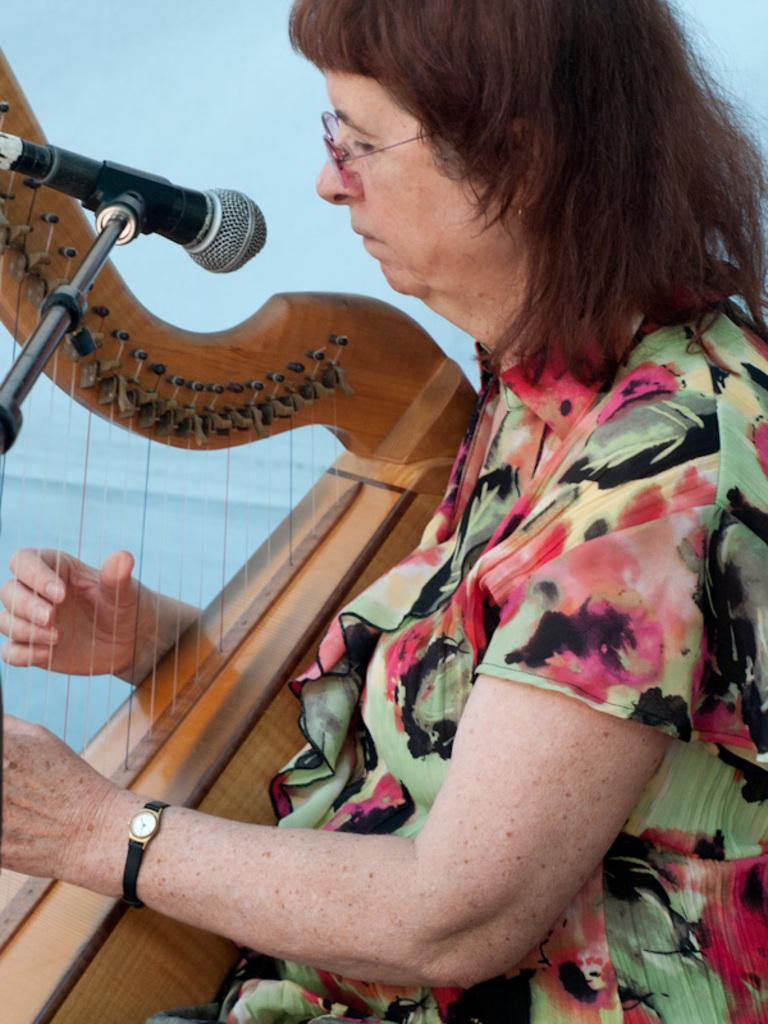What is the main subject of the image? The main subject of the image is a woman. What is the woman doing in the image? The woman is playing a musical instrument in the image. Can you describe the woman's appearance? The woman is wearing spectacles in the image. What other object is present in the image? There is a microphone in the image. What type of cloth is draped over the structure in the image? There is no structure or cloth present in the image; it features a woman playing a musical instrument and wearing spectacles, along with a microphone. 